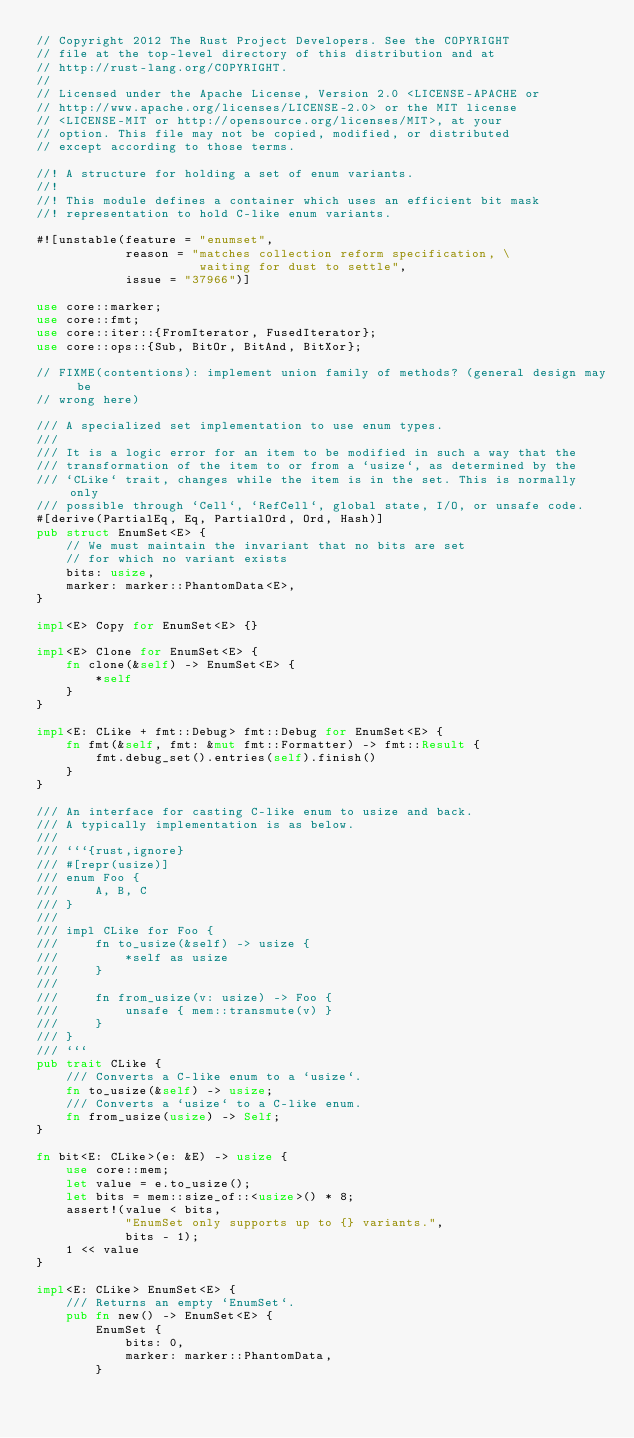<code> <loc_0><loc_0><loc_500><loc_500><_Rust_>// Copyright 2012 The Rust Project Developers. See the COPYRIGHT
// file at the top-level directory of this distribution and at
// http://rust-lang.org/COPYRIGHT.
//
// Licensed under the Apache License, Version 2.0 <LICENSE-APACHE or
// http://www.apache.org/licenses/LICENSE-2.0> or the MIT license
// <LICENSE-MIT or http://opensource.org/licenses/MIT>, at your
// option. This file may not be copied, modified, or distributed
// except according to those terms.

//! A structure for holding a set of enum variants.
//!
//! This module defines a container which uses an efficient bit mask
//! representation to hold C-like enum variants.

#![unstable(feature = "enumset",
            reason = "matches collection reform specification, \
                      waiting for dust to settle",
            issue = "37966")]

use core::marker;
use core::fmt;
use core::iter::{FromIterator, FusedIterator};
use core::ops::{Sub, BitOr, BitAnd, BitXor};

// FIXME(contentions): implement union family of methods? (general design may be
// wrong here)

/// A specialized set implementation to use enum types.
///
/// It is a logic error for an item to be modified in such a way that the
/// transformation of the item to or from a `usize`, as determined by the
/// `CLike` trait, changes while the item is in the set. This is normally only
/// possible through `Cell`, `RefCell`, global state, I/O, or unsafe code.
#[derive(PartialEq, Eq, PartialOrd, Ord, Hash)]
pub struct EnumSet<E> {
    // We must maintain the invariant that no bits are set
    // for which no variant exists
    bits: usize,
    marker: marker::PhantomData<E>,
}

impl<E> Copy for EnumSet<E> {}

impl<E> Clone for EnumSet<E> {
    fn clone(&self) -> EnumSet<E> {
        *self
    }
}

impl<E: CLike + fmt::Debug> fmt::Debug for EnumSet<E> {
    fn fmt(&self, fmt: &mut fmt::Formatter) -> fmt::Result {
        fmt.debug_set().entries(self).finish()
    }
}

/// An interface for casting C-like enum to usize and back.
/// A typically implementation is as below.
///
/// ```{rust,ignore}
/// #[repr(usize)]
/// enum Foo {
///     A, B, C
/// }
///
/// impl CLike for Foo {
///     fn to_usize(&self) -> usize {
///         *self as usize
///     }
///
///     fn from_usize(v: usize) -> Foo {
///         unsafe { mem::transmute(v) }
///     }
/// }
/// ```
pub trait CLike {
    /// Converts a C-like enum to a `usize`.
    fn to_usize(&self) -> usize;
    /// Converts a `usize` to a C-like enum.
    fn from_usize(usize) -> Self;
}

fn bit<E: CLike>(e: &E) -> usize {
    use core::mem;
    let value = e.to_usize();
    let bits = mem::size_of::<usize>() * 8;
    assert!(value < bits,
            "EnumSet only supports up to {} variants.",
            bits - 1);
    1 << value
}

impl<E: CLike> EnumSet<E> {
    /// Returns an empty `EnumSet`.
    pub fn new() -> EnumSet<E> {
        EnumSet {
            bits: 0,
            marker: marker::PhantomData,
        }</code> 